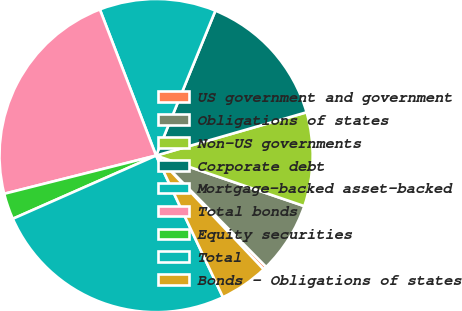Convert chart. <chart><loc_0><loc_0><loc_500><loc_500><pie_chart><fcel>US government and government<fcel>Obligations of states<fcel>Non-US governments<fcel>Corporate debt<fcel>Mortgage-backed asset-backed<fcel>Total bonds<fcel>Equity securities<fcel>Total<fcel>Bonds - Obligations of states<nl><fcel>0.36%<fcel>7.36%<fcel>9.69%<fcel>14.36%<fcel>12.03%<fcel>23.08%<fcel>2.69%<fcel>25.41%<fcel>5.03%<nl></chart> 